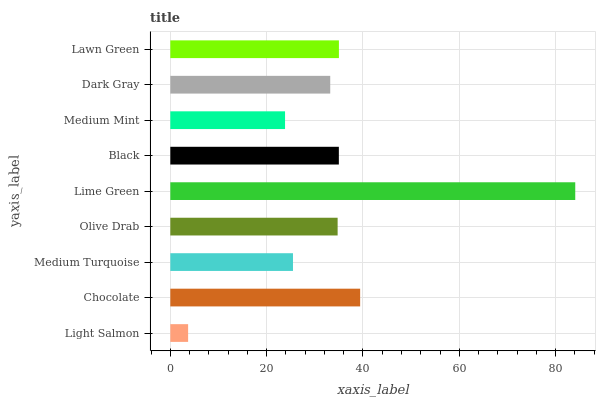Is Light Salmon the minimum?
Answer yes or no. Yes. Is Lime Green the maximum?
Answer yes or no. Yes. Is Chocolate the minimum?
Answer yes or no. No. Is Chocolate the maximum?
Answer yes or no. No. Is Chocolate greater than Light Salmon?
Answer yes or no. Yes. Is Light Salmon less than Chocolate?
Answer yes or no. Yes. Is Light Salmon greater than Chocolate?
Answer yes or no. No. Is Chocolate less than Light Salmon?
Answer yes or no. No. Is Olive Drab the high median?
Answer yes or no. Yes. Is Olive Drab the low median?
Answer yes or no. Yes. Is Black the high median?
Answer yes or no. No. Is Black the low median?
Answer yes or no. No. 